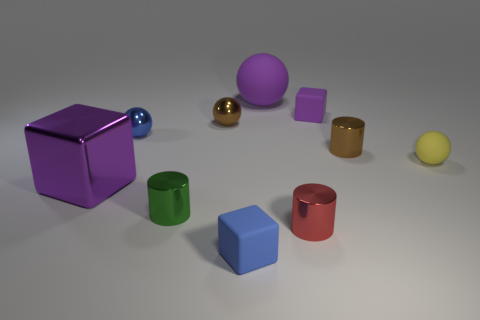Subtract all matte cubes. How many cubes are left? 1 Subtract all purple blocks. How many blocks are left? 1 Subtract all blue cylinders. How many purple blocks are left? 2 Subtract all blocks. How many objects are left? 7 Subtract all big cyan rubber cylinders. Subtract all tiny spheres. How many objects are left? 7 Add 5 small brown metal things. How many small brown metal things are left? 7 Add 3 big green rubber cubes. How many big green rubber cubes exist? 3 Subtract 1 blue spheres. How many objects are left? 9 Subtract 1 balls. How many balls are left? 3 Subtract all yellow blocks. Subtract all gray spheres. How many blocks are left? 3 